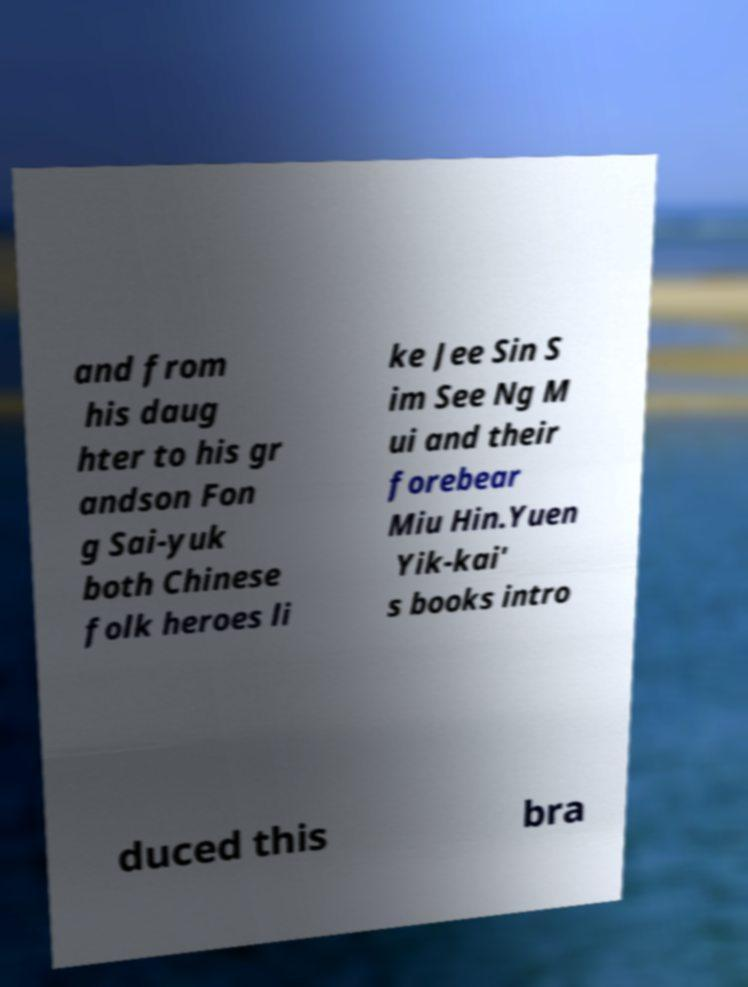Please identify and transcribe the text found in this image. and from his daug hter to his gr andson Fon g Sai-yuk both Chinese folk heroes li ke Jee Sin S im See Ng M ui and their forebear Miu Hin.Yuen Yik-kai' s books intro duced this bra 